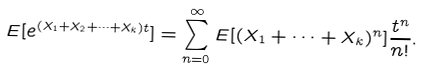<formula> <loc_0><loc_0><loc_500><loc_500>E [ e ^ { ( X _ { 1 } + X _ { 2 } + \cdots + X _ { k } ) t } ] & = \sum _ { n = 0 } ^ { \infty } E [ ( X _ { 1 } + \cdots + X _ { k } ) ^ { n } ] \frac { t ^ { n } } { n ! } .</formula> 